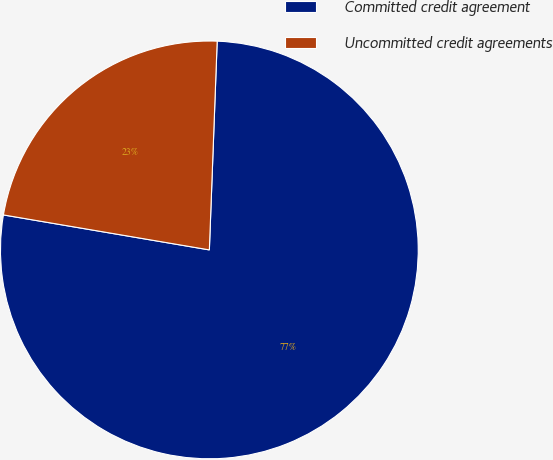<chart> <loc_0><loc_0><loc_500><loc_500><pie_chart><fcel>Committed credit agreement<fcel>Uncommitted credit agreements<nl><fcel>77.08%<fcel>22.92%<nl></chart> 